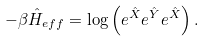<formula> <loc_0><loc_0><loc_500><loc_500>- \beta \hat { H } _ { e f f } = \log \left ( e ^ { \hat { X } } e ^ { \hat { Y } } e ^ { \hat { X } } \right ) .</formula> 